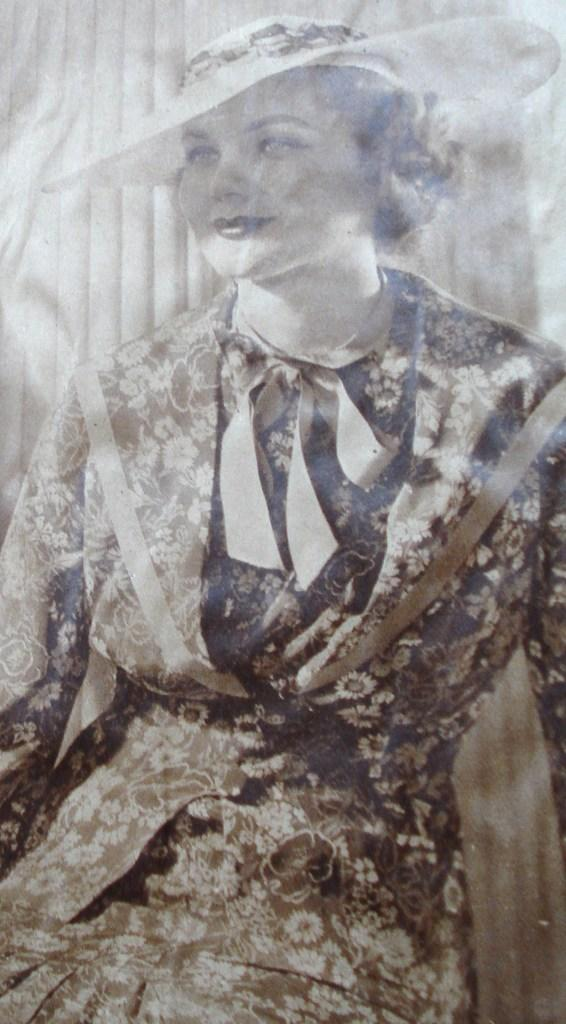Who or what is present in the image? There is a person in the image. What is the person wearing? The person is wearing clothes and a hat. Can you see any beetles crawling on the person's hat in the image? There are no beetles visible in the image. 